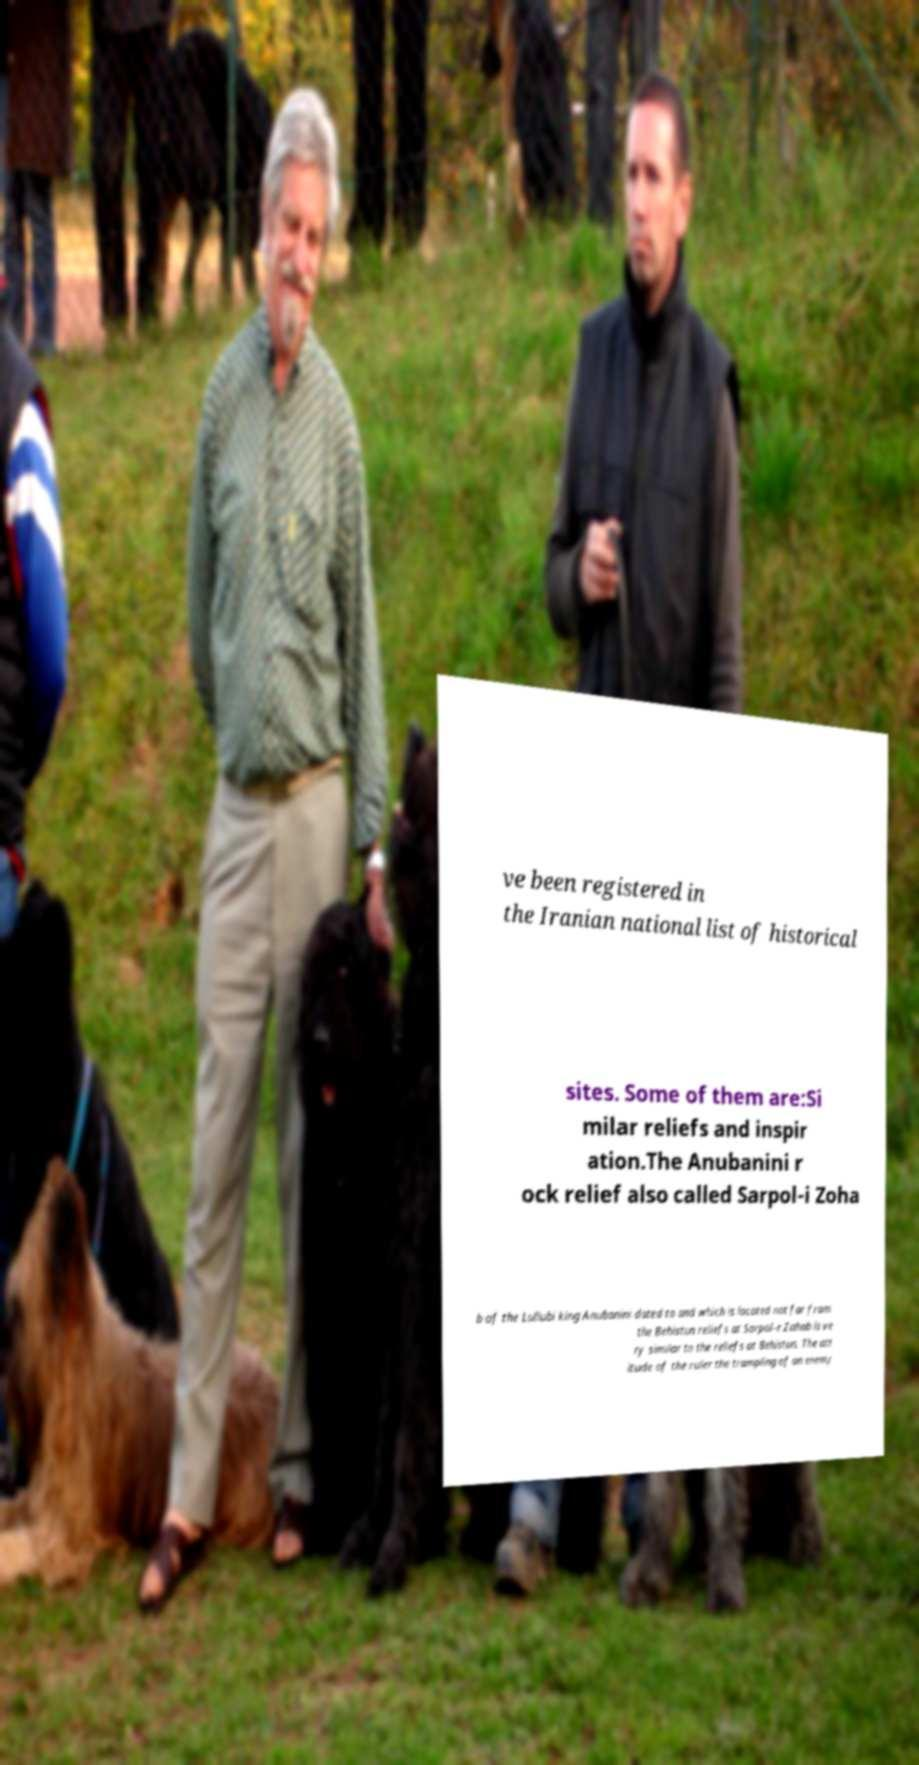Can you accurately transcribe the text from the provided image for me? ve been registered in the Iranian national list of historical sites. Some of them are:Si milar reliefs and inspir ation.The Anubanini r ock relief also called Sarpol-i Zoha b of the Lullubi king Anubanini dated to and which is located not far from the Behistun reliefs at Sarpol-e Zahab is ve ry similar to the reliefs at Behistun. The att itude of the ruler the trampling of an enemy 